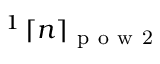Convert formula to latex. <formula><loc_0><loc_0><loc_500><loc_500>^ { 1 } \, \lceil n \rceil _ { p o w 2 }</formula> 